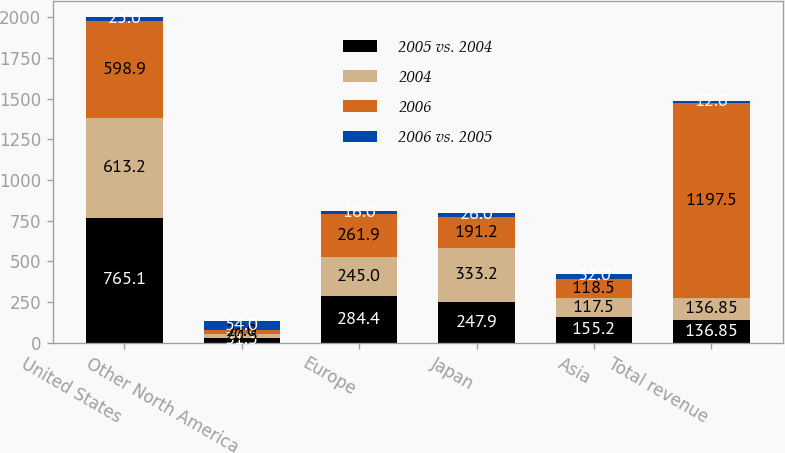Convert chart to OTSL. <chart><loc_0><loc_0><loc_500><loc_500><stacked_bar_chart><ecel><fcel>United States<fcel>Other North America<fcel>Europe<fcel>Japan<fcel>Asia<fcel>Total revenue<nl><fcel>2005 vs. 2004<fcel>765.1<fcel>31.3<fcel>284.4<fcel>247.9<fcel>155.2<fcel>136.85<nl><fcel>2004<fcel>613.2<fcel>20.3<fcel>245<fcel>333.2<fcel>117.5<fcel>136.85<nl><fcel>2006<fcel>598.9<fcel>27<fcel>261.9<fcel>191.2<fcel>118.5<fcel>1197.5<nl><fcel>2006 vs. 2005<fcel>25<fcel>54<fcel>16<fcel>26<fcel>32<fcel>12<nl></chart> 